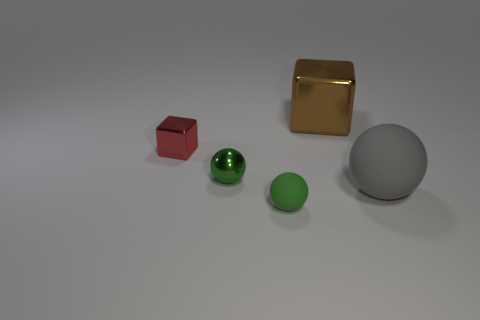Subtract all red blocks. How many blocks are left? 1 Subtract all tiny green balls. How many balls are left? 1 Add 5 blue metal blocks. How many objects exist? 10 Add 4 tiny red cubes. How many tiny red cubes exist? 5 Subtract 0 cyan cubes. How many objects are left? 5 Subtract all spheres. How many objects are left? 2 Subtract 1 cubes. How many cubes are left? 1 Subtract all blue spheres. Subtract all yellow cylinders. How many spheres are left? 3 Subtract all cyan spheres. How many cyan blocks are left? 0 Subtract all large blue things. Subtract all gray balls. How many objects are left? 4 